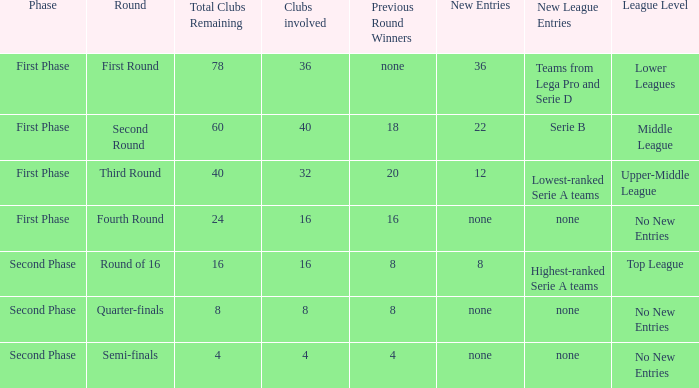Considering 8 clubs are taking part, what numerical value can be obtained from the winners in the last round? 8.0. 